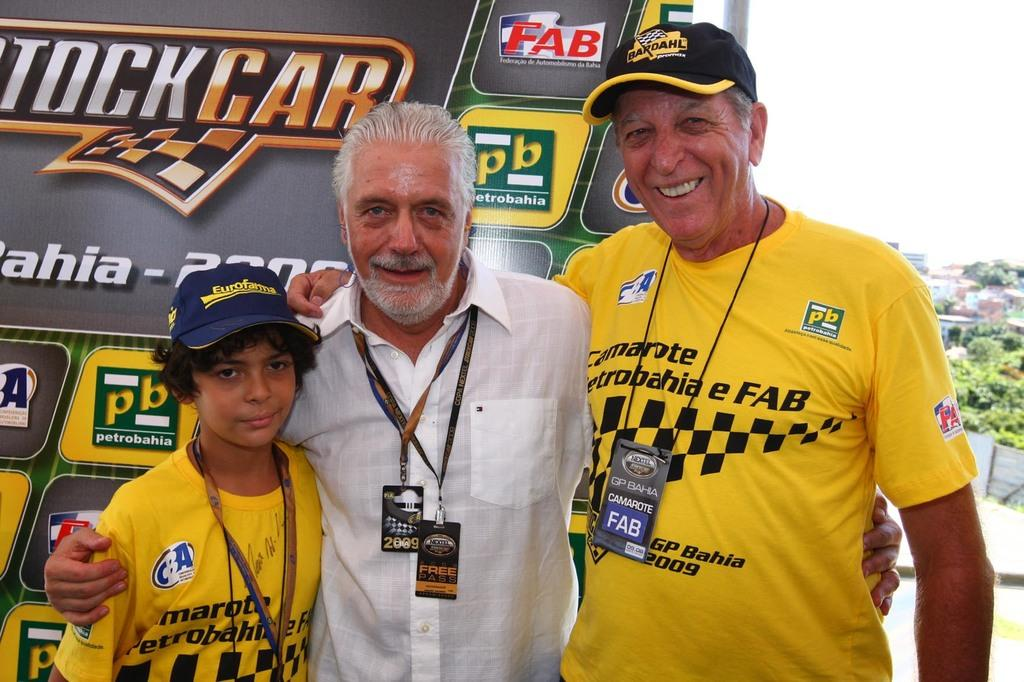<image>
Give a short and clear explanation of the subsequent image. a few people posing and two have the word fab on their shirts 